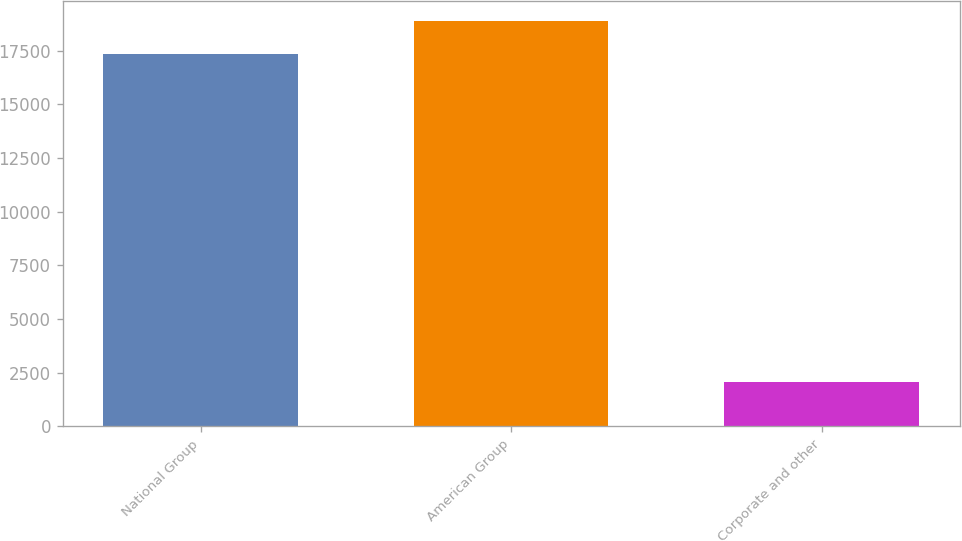Convert chart to OTSL. <chart><loc_0><loc_0><loc_500><loc_500><bar_chart><fcel>National Group<fcel>American Group<fcel>Corporate and other<nl><fcel>17325<fcel>18872.1<fcel>2061<nl></chart> 